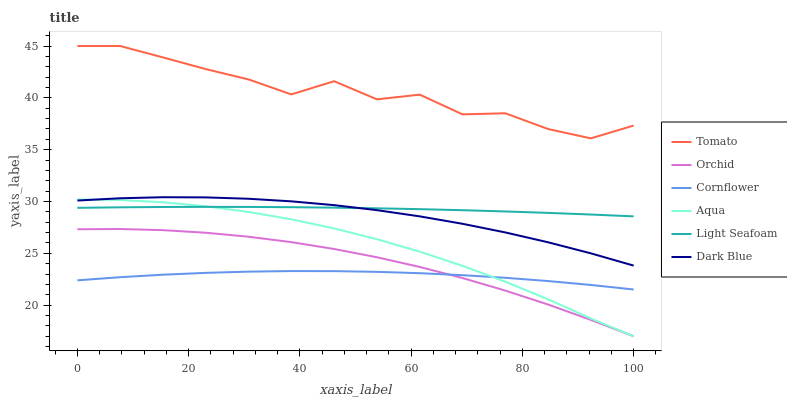Does Cornflower have the minimum area under the curve?
Answer yes or no. Yes. Does Tomato have the maximum area under the curve?
Answer yes or no. Yes. Does Aqua have the minimum area under the curve?
Answer yes or no. No. Does Aqua have the maximum area under the curve?
Answer yes or no. No. Is Light Seafoam the smoothest?
Answer yes or no. Yes. Is Tomato the roughest?
Answer yes or no. Yes. Is Cornflower the smoothest?
Answer yes or no. No. Is Cornflower the roughest?
Answer yes or no. No. Does Cornflower have the lowest value?
Answer yes or no. No. Does Aqua have the highest value?
Answer yes or no. No. Is Cornflower less than Tomato?
Answer yes or no. Yes. Is Tomato greater than Aqua?
Answer yes or no. Yes. Does Cornflower intersect Tomato?
Answer yes or no. No. 